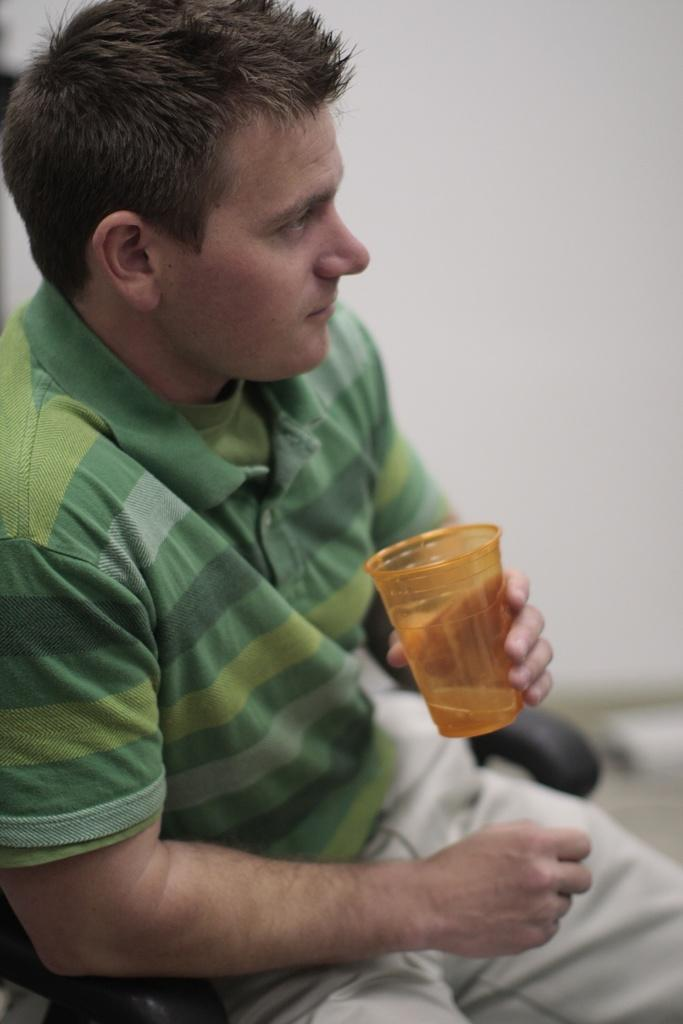Who is present in the image? There is a man in the image. What is the man wearing? The man is wearing a t-shirt. What is the man holding in his hand? The man is holding a glass in his hand. What is the man's position in the image? The man is sitting on a chair and facing towards the right side. What can be seen in the background of the image? There is a wall in the background of the image. What type of flesh can be seen on the man's desk in the image? There is no desk present in the image, and therefore no flesh can be seen on it. 